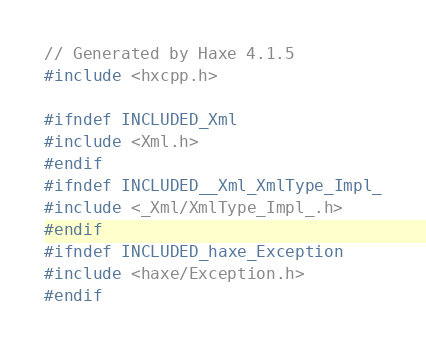<code> <loc_0><loc_0><loc_500><loc_500><_C++_>// Generated by Haxe 4.1.5
#include <hxcpp.h>

#ifndef INCLUDED_Xml
#include <Xml.h>
#endif
#ifndef INCLUDED__Xml_XmlType_Impl_
#include <_Xml/XmlType_Impl_.h>
#endif
#ifndef INCLUDED_haxe_Exception
#include <haxe/Exception.h>
#endif</code> 